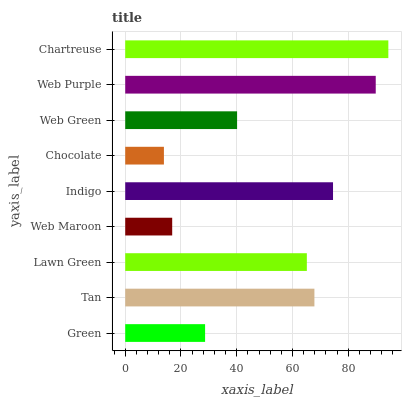Is Chocolate the minimum?
Answer yes or no. Yes. Is Chartreuse the maximum?
Answer yes or no. Yes. Is Tan the minimum?
Answer yes or no. No. Is Tan the maximum?
Answer yes or no. No. Is Tan greater than Green?
Answer yes or no. Yes. Is Green less than Tan?
Answer yes or no. Yes. Is Green greater than Tan?
Answer yes or no. No. Is Tan less than Green?
Answer yes or no. No. Is Lawn Green the high median?
Answer yes or no. Yes. Is Lawn Green the low median?
Answer yes or no. Yes. Is Web Green the high median?
Answer yes or no. No. Is Chartreuse the low median?
Answer yes or no. No. 